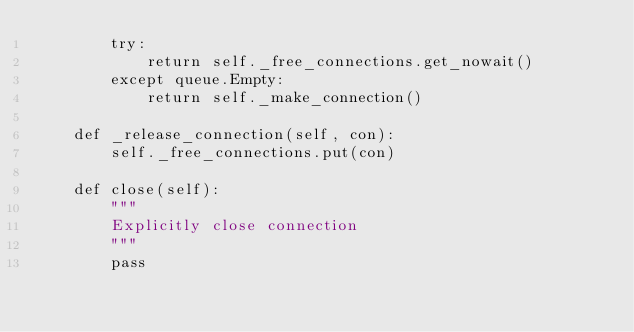<code> <loc_0><loc_0><loc_500><loc_500><_Python_>        try:
            return self._free_connections.get_nowait()
        except queue.Empty:
            return self._make_connection()

    def _release_connection(self, con):
        self._free_connections.put(con)

    def close(self):
        """
        Explicitly close connection
        """
        pass
</code> 